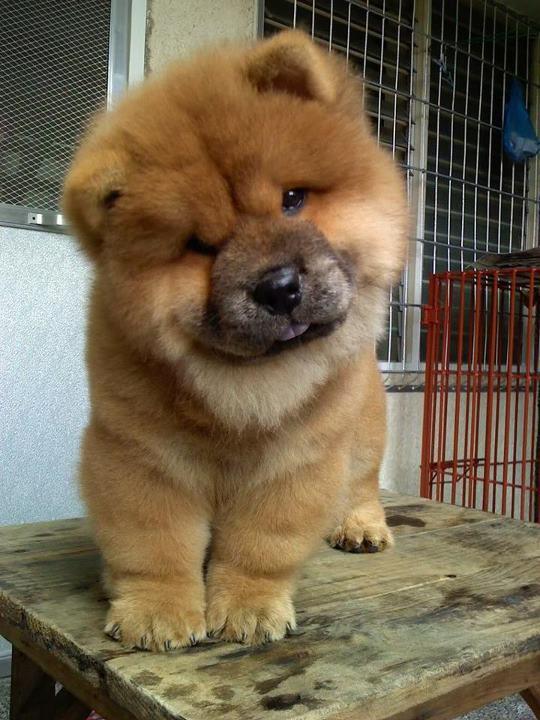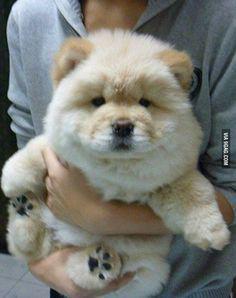The first image is the image on the left, the second image is the image on the right. For the images shown, is this caption "One of the images features a dog laying down." true? Answer yes or no. No. The first image is the image on the left, the second image is the image on the right. For the images shown, is this caption "Each image contains exactly one chow pup, and the pup that has darker, non-blond fur is standing on all fours." true? Answer yes or no. Yes. 